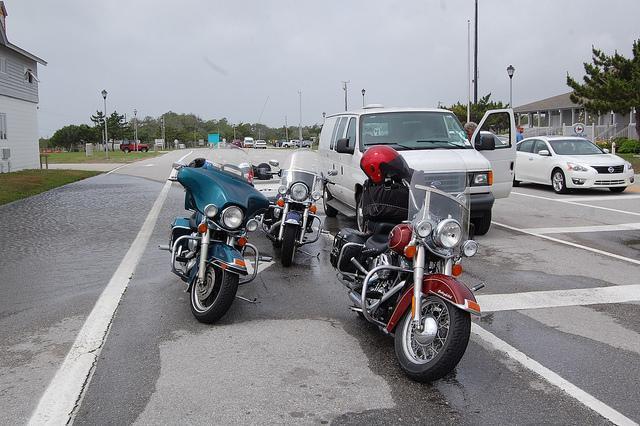How many motorcycles have riders?
Give a very brief answer. 0. How many people are on the motorcycle?
Give a very brief answer. 0. How many cars are there?
Give a very brief answer. 2. How many motorcycles are visible?
Give a very brief answer. 3. How many cows are there?
Give a very brief answer. 0. 